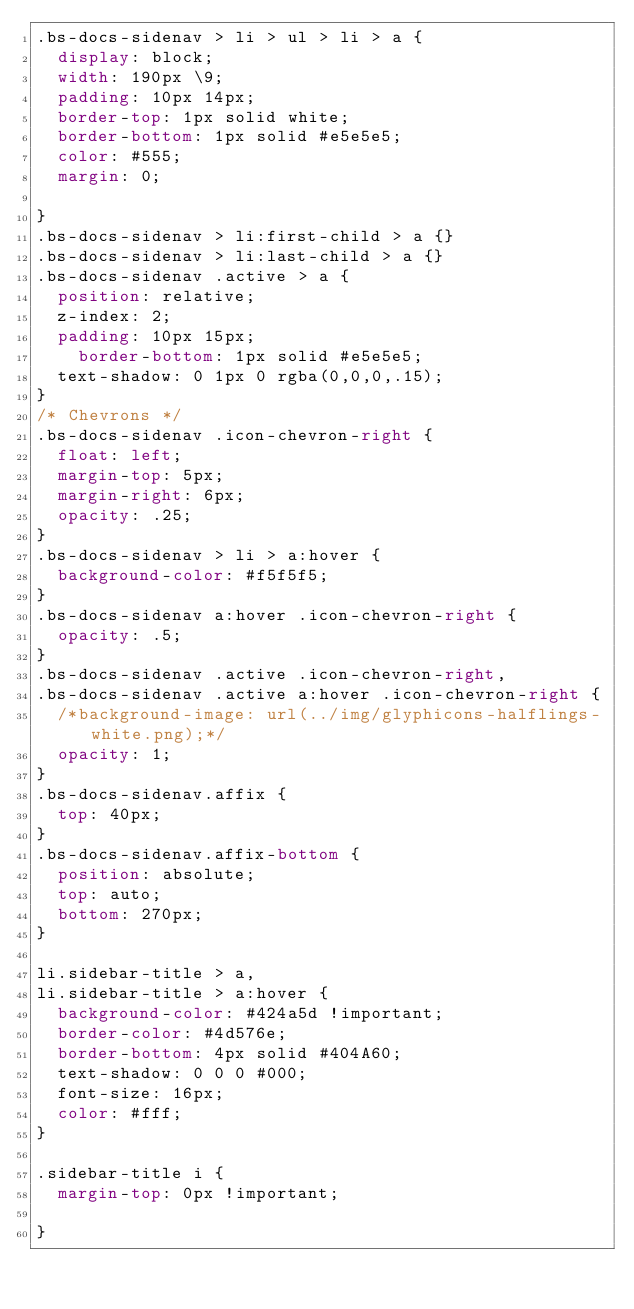Convert code to text. <code><loc_0><loc_0><loc_500><loc_500><_CSS_>.bs-docs-sidenav > li > ul > li > a {
  display: block;
  width: 190px \9;
  padding: 10px 14px;
  border-top: 1px solid white;
  border-bottom: 1px solid #e5e5e5;
  color: #555;
  margin: 0;
  
}
.bs-docs-sidenav > li:first-child > a {}
.bs-docs-sidenav > li:last-child > a {}
.bs-docs-sidenav .active > a {
  position: relative;
  z-index: 2;
  padding: 10px 15px;
    border-bottom: 1px solid #e5e5e5;
  text-shadow: 0 1px 0 rgba(0,0,0,.15);
}
/* Chevrons */
.bs-docs-sidenav .icon-chevron-right {
  float: left;
  margin-top: 5px;
  margin-right: 6px;
  opacity: .25;
}
.bs-docs-sidenav > li > a:hover {
  background-color: #f5f5f5;
}
.bs-docs-sidenav a:hover .icon-chevron-right {
  opacity: .5;
}
.bs-docs-sidenav .active .icon-chevron-right,
.bs-docs-sidenav .active a:hover .icon-chevron-right {
  /*background-image: url(../img/glyphicons-halflings-white.png);*/
  opacity: 1;
}
.bs-docs-sidenav.affix {
  top: 40px;
}
.bs-docs-sidenav.affix-bottom {
  position: absolute;
  top: auto;
  bottom: 270px;
}

li.sidebar-title > a,
li.sidebar-title > a:hover {
	background-color: #424a5d !important;
	border-color: #4d576e;
	border-bottom: 4px solid #404A60;
	text-shadow: 0 0 0 #000;
	font-size: 16px;
	color: #fff;
}

.sidebar-title i {
	margin-top: 0px !important;
	
}

</code> 